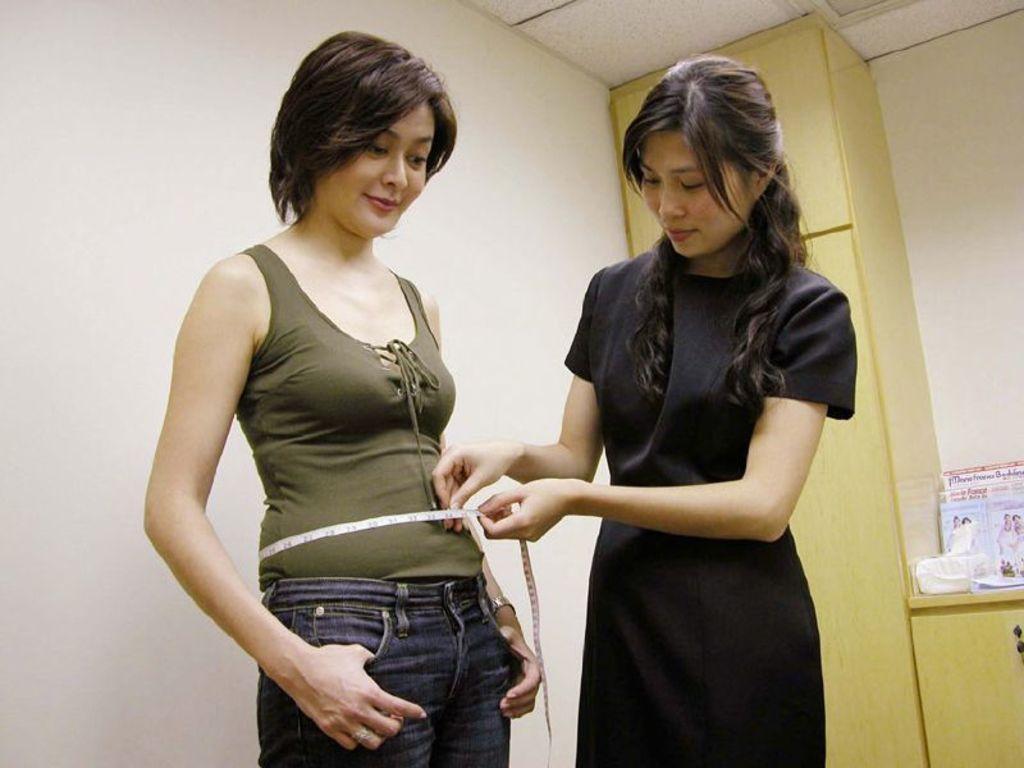Please provide a concise description of this image. Here I can see two women standing and smiling. The woman who is on the right side is holding a measuring tape. In the background there is a wall. On the right side there is a table on which few papers and some other objects are placed. Beside there is a cupboard. 